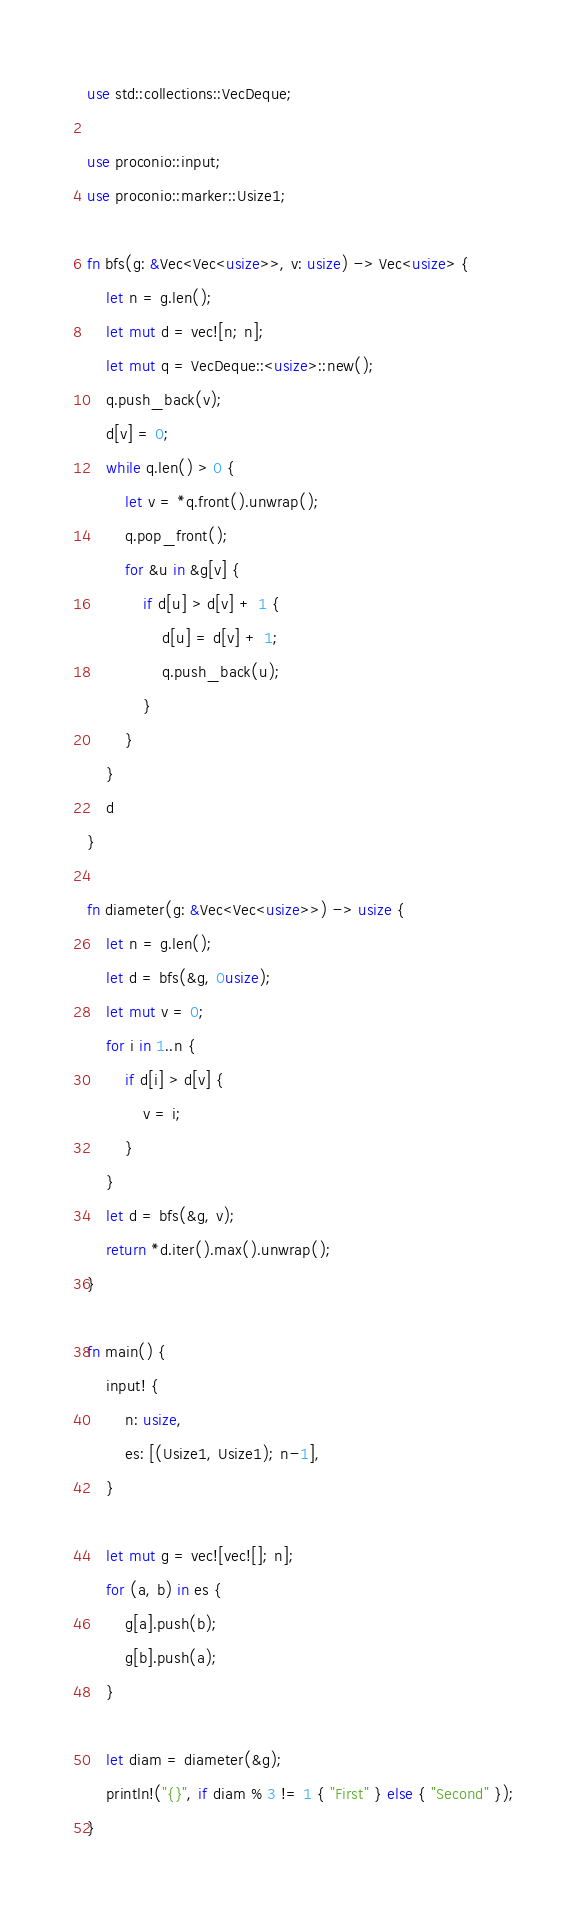<code> <loc_0><loc_0><loc_500><loc_500><_Rust_>use std::collections::VecDeque;

use proconio::input;
use proconio::marker::Usize1;

fn bfs(g: &Vec<Vec<usize>>, v: usize) -> Vec<usize> {
    let n = g.len();
    let mut d = vec![n; n];
    let mut q = VecDeque::<usize>::new();
    q.push_back(v);
    d[v] = 0;
    while q.len() > 0 {
        let v = *q.front().unwrap();
        q.pop_front();
        for &u in &g[v] {
            if d[u] > d[v] + 1 {
                d[u] = d[v] + 1;
                q.push_back(u);
            }
        }
    }
    d
}

fn diameter(g: &Vec<Vec<usize>>) -> usize {
    let n = g.len();
    let d = bfs(&g, 0usize);
    let mut v = 0;
    for i in 1..n {
        if d[i] > d[v] {
            v = i;
        }
    }
    let d = bfs(&g, v);
    return *d.iter().max().unwrap();
}

fn main() {
    input! {
        n: usize,
        es: [(Usize1, Usize1); n-1],
    }

    let mut g = vec![vec![]; n];
    for (a, b) in es {
        g[a].push(b);
        g[b].push(a);
    }

    let diam = diameter(&g);
    println!("{}", if diam % 3 != 1 { "First" } else { "Second" });
}
</code> 